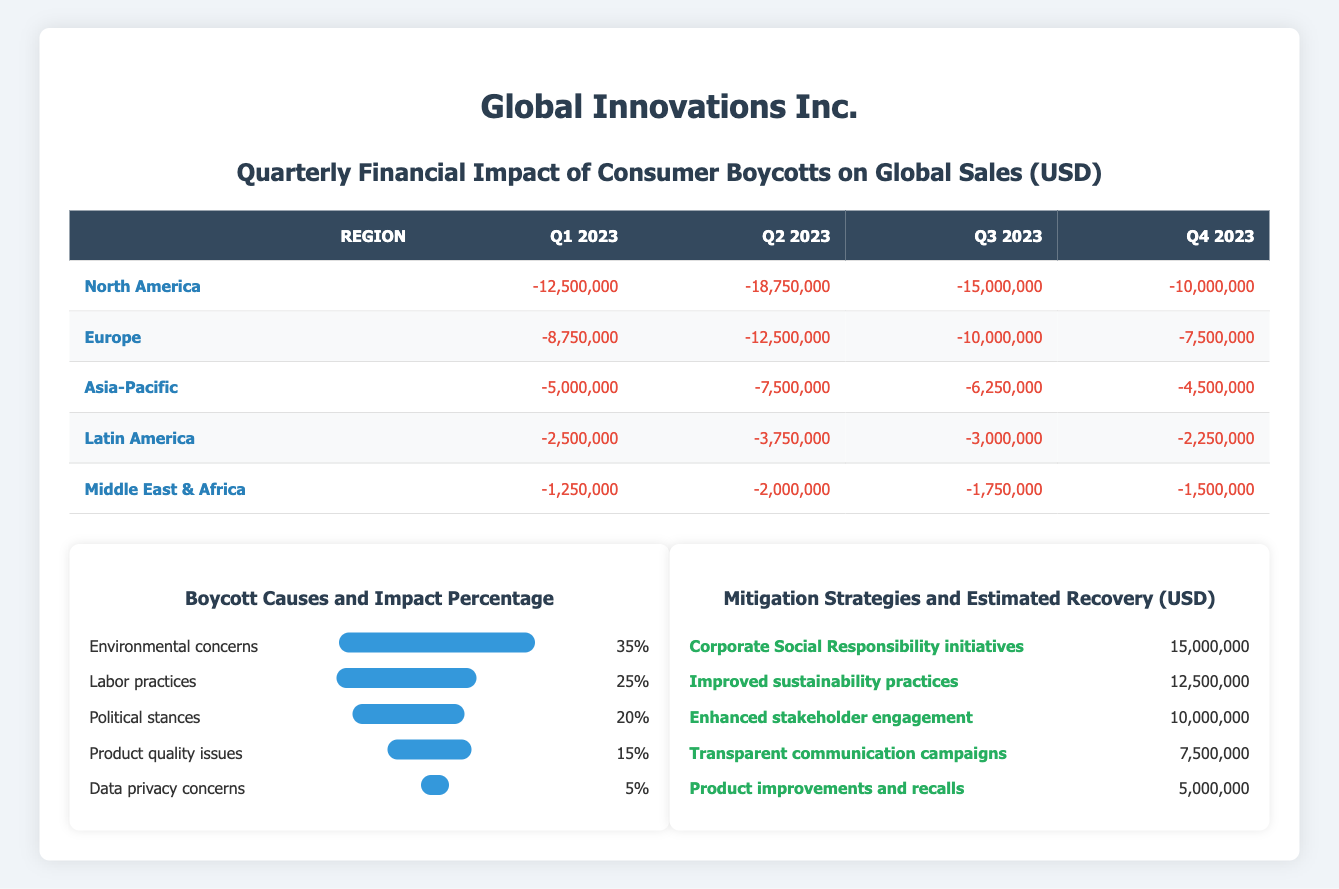What is the total sales impact from boycotts in North America for Q2 2023? The sales impact for North America in Q2 2023 is -18,750,000, which can be found directly in the table under that specific quarter and region.
Answer: -18,750,000 Which region experienced the highest sales impact due to boycotts in Q3 2023? In Q3 2023, North America had the most significant impact with a value of -15,000,000. By comparing all regions' values for Q3, it is clear that North America has the highest negative impact.
Answer: North America What is the average boycott impact across all regions for Q1 2023? To find the average impact for Q1 2023, we sum the negative impacts: -12,500,000 + -8,750,000 + -5,000,000 + -2,500,000 + -1,250,000 = -30,000,000. There are 5 regions, so the average is -30,000,000 / 5 = -6,000,000.
Answer: -6,000,000 Did the sales impact in Europe decrease from Q3 2023 to Q4 2023? The sales impact in Europe for Q3 2023 is -10,000,000, and for Q4 2023 it is -7,500,000. Since -7,500,000 is greater (less negative) than -10,000,000, we conclude that the impact decreased.
Answer: Yes What was the total estimated recovery from mitigation strategies for three specific strategies listed? The total estimated recovery from the three highest strategies is 15,000,000 + 12,500,000 + 10,000,000 = 37,500,000. This is calculated by directly adding the estimated recovery values for Corporate Social Responsibility initiatives, Improved sustainability practices, and Enhanced stakeholder engagement.
Answer: 37,500,000 Was Latin America the least impacted region in Q4 2023? In Q4 2023, the impact for Latin America is -2,250,000, and when comparing this with the other regions, it is indeed the least negative value. Therefore, this statement is true.
Answer: Yes How much more significant was the boycott impact in Asia-Pacific compared to Middle East & Africa in Q2 2023? The boycott impact for Asia-Pacific in Q2 2023 is -7,500,000, and for Middle East & Africa, it is -2,000,000. The difference between them is -7,500,000 - (-2,000,000) = -5,500,000, showing that Asia-Pacific was impacted more by this value.
Answer: -5,500,000 What is the cumulative boycotting impact across all regions for the entire year of 2023? The cumulative impact for all four quarters is calculated by summing the impacts for each region and quarter. For the entire year, adding the quarterly impacts gives -30,000,000 (Q1) + -50,000,000 (Q2) + -38,750,000 (Q3) + -27,500,000 (Q4) = -146,250,000.
Answer: -146,250,000 Which boycott cause had the greatest impact percentage based on the provided data? The data states that environmental concerns had the highest impact percentage at 35%. This is evident from comparing the impact percentages listed for each cause.
Answer: Environmental concerns 